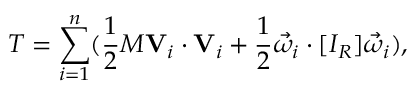<formula> <loc_0><loc_0><loc_500><loc_500>T = \sum _ { i = 1 } ^ { n } ( { \frac { 1 } { 2 } } M V _ { i } \cdot V _ { i } + { \frac { 1 } { 2 } } { \vec { \omega } } _ { i } \cdot [ I _ { R } ] { \vec { \omega } } _ { i } ) ,</formula> 